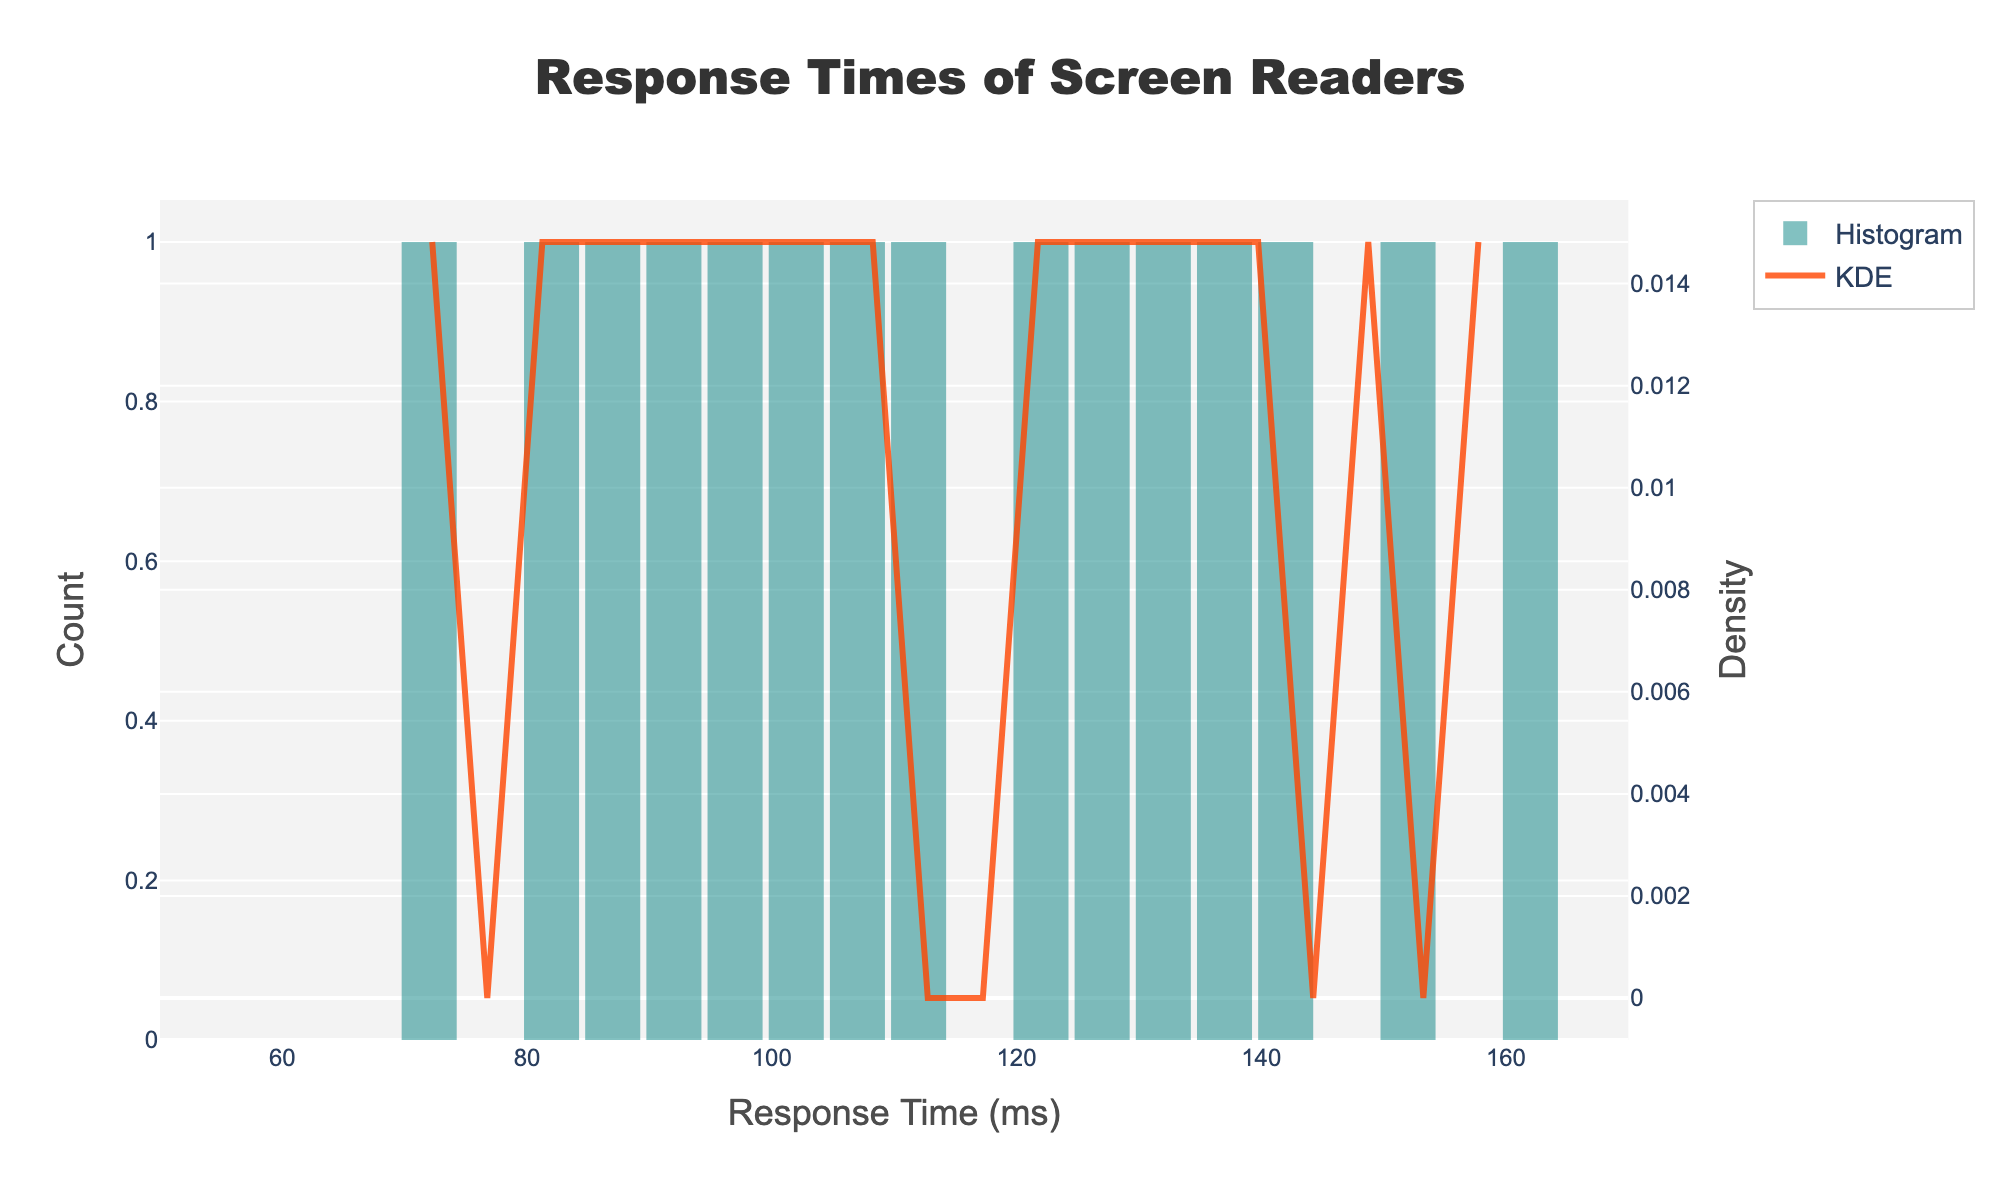What is the title of the figure? The title is usually located at the top of the figure. It provides a summary of what the figure is about.
Answer: Response Times of Screen Readers What are the x-axis and y-axis titles? The x-axis and y-axis titles are found along the horizontal and vertical axes respectively. They describe what each axis represents. The x-axis title is 'Response Time (ms)', and the primary y-axis title is 'Count' while the secondary y-axis title is 'Density'.
Answer: x-axis: 'Response Time (ms)', y-axis: 'Count', secondary y-axis: 'Density' What is the color of the histogram bars? The color of the histogram bars can be identified by observing the bars in the figure. They are colored in a semi-transparent teal shade.
Answer: Teal Where is the density curve located in the figure and what color is it? The density curve (KDE) is located overlayed on the histogram bars. It is represented by a line and is colored in a semi-transparent orange shade.
Answer: Overlayed on the histogram, Orange How many bins are there in the histogram? The number of bins in the histogram is the number of vertical bars representing data intervals. From the code and visually inspecting the figure, there are 20 bins.
Answer: 20 What is the approximate response time range where the highest density is observed? To find the response time range with the highest density, observe the KDE curve. The peak of the density curve indicates the highest density, which is around the 80-100 milliseconds range.
Answer: 80-100 ms What is the range of response times shown on the x-axis? The range of response times can be identified from the horizontal span of the x-axis. From the tick marks, it ranges from 50 to 170 milliseconds.
Answer: 50 to 170 ms Comparing the counts, which response time interval has the highest count? To find the interval with the highest count, observe the tallest histogram bar. It indicates the response time interval with the highest count, which is around 80-100 milliseconds.
Answer: 80-100 ms What can be inferred about the distribution shape from the KDE curve? The shape of the KDE curve provides insights into the distribution. A single peak suggests a unimodal distribution, and the right-skewed nature indicates that most response times are on the lower side, with fewer instances of higher response times.
Answer: Unimodal, Right-skewed What response time interval shows the lowest density? To determine the interval with the lowest density, examine the KDE curve for the lowest points. This can be observed at the extreme ends, specifically around the 120-170 milliseconds range.
Answer: 120-170 ms 